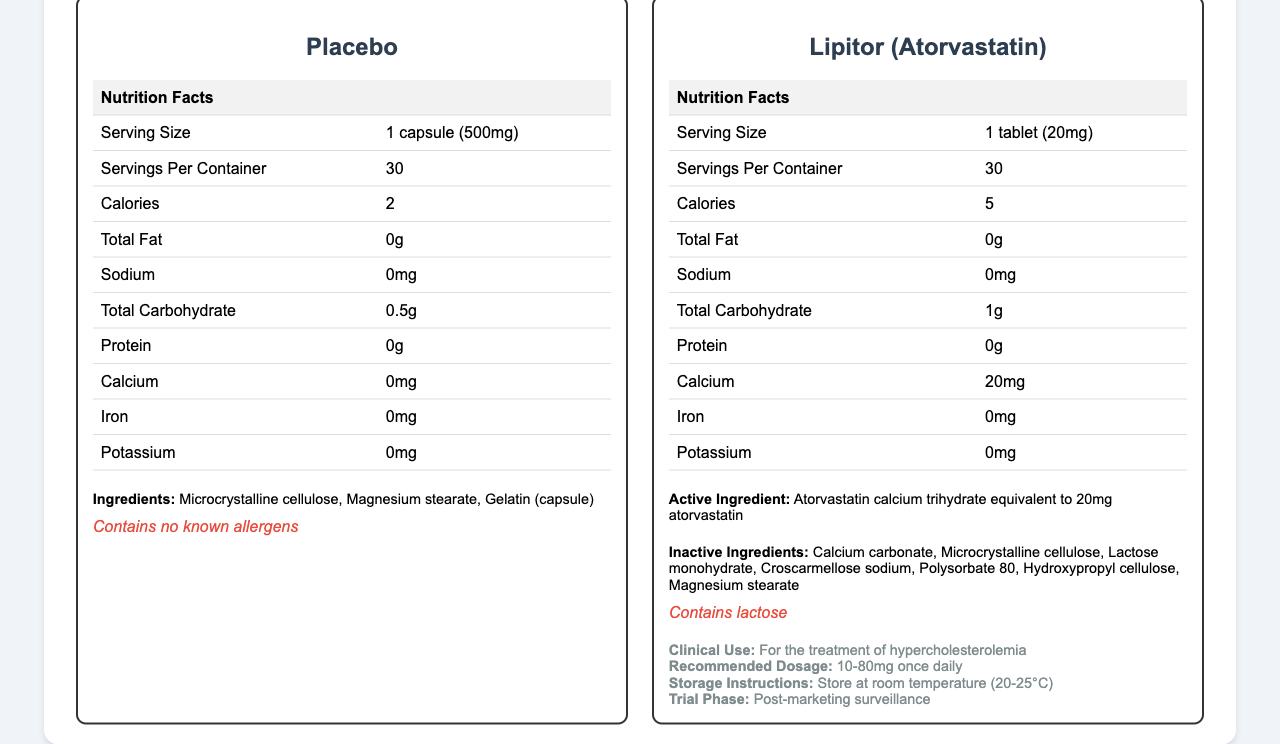what is the serving size for the placebo? The serving size for the placebo is listed as "1 capsule (500mg)" in the document.
Answer: 1 capsule (500mg) what is the serving size for Lipitor (Atorvastatin)? The serving size for Lipitor (Atorvastatin) is listed as "1 tablet (20mg)" in the document.
Answer: 1 tablet (20mg) what is the total carbohydrate content in the placebo? The total carbohydrate content in the placebo is listed as "0.5g" in the document.
Answer: 0.5g what are the inactive ingredients in Lipitor (Atorvastatin)? The inactive ingredients in Lipitor (Atorvastatin) are listed in the document.
Answer: Calcium carbonate, Microcrystalline cellulose, Lactose monohydrate, Croscarmellose sodium, Polysorbate 80, Hydroxypropyl cellulose, Magnesium stearate does the placebo contain calcium? The document lists the calcium content for the placebo as "0mg."
Answer: No which of the following is a potential adverse effect of Lipitor (Atorvastatin)? A. Cough B. Myalgia C. Drowsiness D. Rash The document lists "Myalgia" as one of the adverse effects of Lipitor (Atorvastatin).
Answer: B how many calories are in one serving of Lipitor (Atorvastatin)? A. 2 B. 4 C. 5 D. 7 The document lists the calorie content for Lipitor (Atorvastatin) as "5."
Answer: C does the document provide the recommended dosage for Lipitor (Atorvastatin)? The recommended dosage "10-80mg once daily" is provided in the document.
Answer: Yes summarize the main idea of the document. The document visually presents a comparative analysis between a placebo and an active pharmaceutical ingredient (Lipitor), with detailed nutrition facts, clinical use information, and study-related details.
Answer: The document compares the nutritional profile of a placebo capsule and Lipitor (Atorvastatin), detailing serving sizes, nutritional contents, ingredients, allergen information, clinical use, and recommended dosage for Lipitor, alongside additional study details and regulatory considerations. what is the primary endpoint of the study associated with Lipitor (Atorvastatin)? The primary endpoint of the study named "ASCOT-LLA" is listed as "Reduction in LDL cholesterol levels" in the document.
Answer: Reduction in LDL cholesterol levels how long was the duration of the study? The duration of the study is noted as "3.3 years (median)" in the document.
Answer: 3.3 years (median) what is the sample size of the study? The document lists the sample size of the study as "10305."
Answer: 10305 does the placebo capsule contain any known allergens? The document states that the placebo "Contains no known allergens."
Answer: No what is the significance level used in the statistical analysis of the study? The document lists the significance level for the statistical analysis as "0.05."
Answer: 0.05 how is the sample size for the Lipitor (Atorvastatin) study related to the power calculation? The document states that the statistical analysis had "90% power to detect a 25% reduction in primary endpoint."
Answer: 90% power to detect a 25% reduction in primary endpoint what are the exclusion criteria of the study? The exclusion criteria listed in the document are "Previous myocardial infarction," "Currently treated angina," and "Cerebrovascular event within previous 3 months."
Answer: Previous myocardial infarction, Currently treated angina, Cerebrovascular event within previous 3 months does Lipitor (Atorvastatin) tablet include sodium? The document lists the sodium content for Lipitor as "0mg."
Answer: No what are the storage instructions for Lipitor (Atorvastatin)? The storage instructions for Lipitor are listed as "Store at room temperature (20-25°C)" in the document.
Answer: Store at room temperature (20-25°C) what allergen does Lipitor (Atorvastatin) contain? The allergen information for Lipitor states that it "Contains lactose."
Answer: Lactose how often should the dosage of Lipitor (Atorvastatin) be taken as per the recommended dosage? The recommended dosage "10-80mg once daily" clearly mentions that it should be taken once daily.
Answer: Once daily what is the median duration of the study? The median duration of the study is listed as "3.3 years" in the document.
Answer: 3.3 years are there any previous cardiovascular events within 3 months mentioned in the exclusion criteria for the study? "Cerebrovascular event within previous 3 months" is listed as an exclusion criterion for the study.
Answer: Yes 